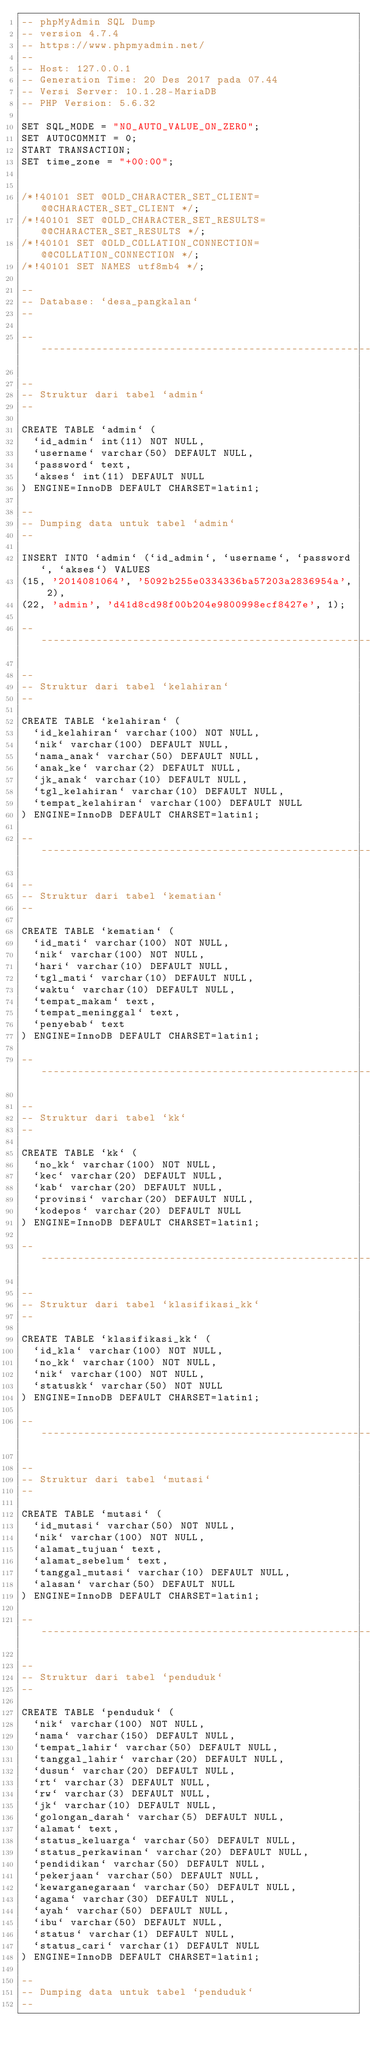Convert code to text. <code><loc_0><loc_0><loc_500><loc_500><_SQL_>-- phpMyAdmin SQL Dump
-- version 4.7.4
-- https://www.phpmyadmin.net/
--
-- Host: 127.0.0.1
-- Generation Time: 20 Des 2017 pada 07.44
-- Versi Server: 10.1.28-MariaDB
-- PHP Version: 5.6.32

SET SQL_MODE = "NO_AUTO_VALUE_ON_ZERO";
SET AUTOCOMMIT = 0;
START TRANSACTION;
SET time_zone = "+00:00";


/*!40101 SET @OLD_CHARACTER_SET_CLIENT=@@CHARACTER_SET_CLIENT */;
/*!40101 SET @OLD_CHARACTER_SET_RESULTS=@@CHARACTER_SET_RESULTS */;
/*!40101 SET @OLD_COLLATION_CONNECTION=@@COLLATION_CONNECTION */;
/*!40101 SET NAMES utf8mb4 */;

--
-- Database: `desa_pangkalan`
--

-- --------------------------------------------------------

--
-- Struktur dari tabel `admin`
--

CREATE TABLE `admin` (
  `id_admin` int(11) NOT NULL,
  `username` varchar(50) DEFAULT NULL,
  `password` text,
  `akses` int(11) DEFAULT NULL
) ENGINE=InnoDB DEFAULT CHARSET=latin1;

--
-- Dumping data untuk tabel `admin`
--

INSERT INTO `admin` (`id_admin`, `username`, `password`, `akses`) VALUES
(15, '2014081064', '5092b255e0334336ba57203a2836954a', 2),
(22, 'admin', 'd41d8cd98f00b204e9800998ecf8427e', 1);

-- --------------------------------------------------------

--
-- Struktur dari tabel `kelahiran`
--

CREATE TABLE `kelahiran` (
  `id_kelahiran` varchar(100) NOT NULL,
  `nik` varchar(100) DEFAULT NULL,
  `nama_anak` varchar(50) DEFAULT NULL,
  `anak_ke` varchar(2) DEFAULT NULL,
  `jk_anak` varchar(10) DEFAULT NULL,
  `tgl_kelahiran` varchar(10) DEFAULT NULL,
  `tempat_kelahiran` varchar(100) DEFAULT NULL
) ENGINE=InnoDB DEFAULT CHARSET=latin1;

-- --------------------------------------------------------

--
-- Struktur dari tabel `kematian`
--

CREATE TABLE `kematian` (
  `id_mati` varchar(100) NOT NULL,
  `nik` varchar(100) NOT NULL,
  `hari` varchar(10) DEFAULT NULL,
  `tgl_mati` varchar(10) DEFAULT NULL,
  `waktu` varchar(10) DEFAULT NULL,
  `tempat_makam` text,
  `tempat_meninggal` text,
  `penyebab` text
) ENGINE=InnoDB DEFAULT CHARSET=latin1;

-- --------------------------------------------------------

--
-- Struktur dari tabel `kk`
--

CREATE TABLE `kk` (
  `no_kk` varchar(100) NOT NULL,
  `kec` varchar(20) DEFAULT NULL,
  `kab` varchar(20) DEFAULT NULL,
  `provinsi` varchar(20) DEFAULT NULL,
  `kodepos` varchar(20) DEFAULT NULL
) ENGINE=InnoDB DEFAULT CHARSET=latin1;

-- --------------------------------------------------------

--
-- Struktur dari tabel `klasifikasi_kk`
--

CREATE TABLE `klasifikasi_kk` (
  `id_kla` varchar(100) NOT NULL,
  `no_kk` varchar(100) NOT NULL,
  `nik` varchar(100) NOT NULL,
  `statuskk` varchar(50) NOT NULL
) ENGINE=InnoDB DEFAULT CHARSET=latin1;

-- --------------------------------------------------------

--
-- Struktur dari tabel `mutasi`
--

CREATE TABLE `mutasi` (
  `id_mutasi` varchar(50) NOT NULL,
  `nik` varchar(100) NOT NULL,
  `alamat_tujuan` text,
  `alamat_sebelum` text,
  `tanggal_mutasi` varchar(10) DEFAULT NULL,
  `alasan` varchar(50) DEFAULT NULL
) ENGINE=InnoDB DEFAULT CHARSET=latin1;

-- --------------------------------------------------------

--
-- Struktur dari tabel `penduduk`
--

CREATE TABLE `penduduk` (
  `nik` varchar(100) NOT NULL,
  `nama` varchar(150) DEFAULT NULL,
  `tempat_lahir` varchar(50) DEFAULT NULL,
  `tanggal_lahir` varchar(20) DEFAULT NULL,
  `dusun` varchar(20) DEFAULT NULL,
  `rt` varchar(3) DEFAULT NULL,
  `rw` varchar(3) DEFAULT NULL,
  `jk` varchar(10) DEFAULT NULL,
  `golongan_darah` varchar(5) DEFAULT NULL,
  `alamat` text,
  `status_keluarga` varchar(50) DEFAULT NULL,
  `status_perkawinan` varchar(20) DEFAULT NULL,
  `pendidikan` varchar(50) DEFAULT NULL,
  `pekerjaan` varchar(50) DEFAULT NULL,
  `kewarganegaraan` varchar(50) DEFAULT NULL,
  `agama` varchar(30) DEFAULT NULL,
  `ayah` varchar(50) DEFAULT NULL,
  `ibu` varchar(50) DEFAULT NULL,
  `status` varchar(1) DEFAULT NULL,
  `status_cari` varchar(1) DEFAULT NULL
) ENGINE=InnoDB DEFAULT CHARSET=latin1;

--
-- Dumping data untuk tabel `penduduk`
--
</code> 